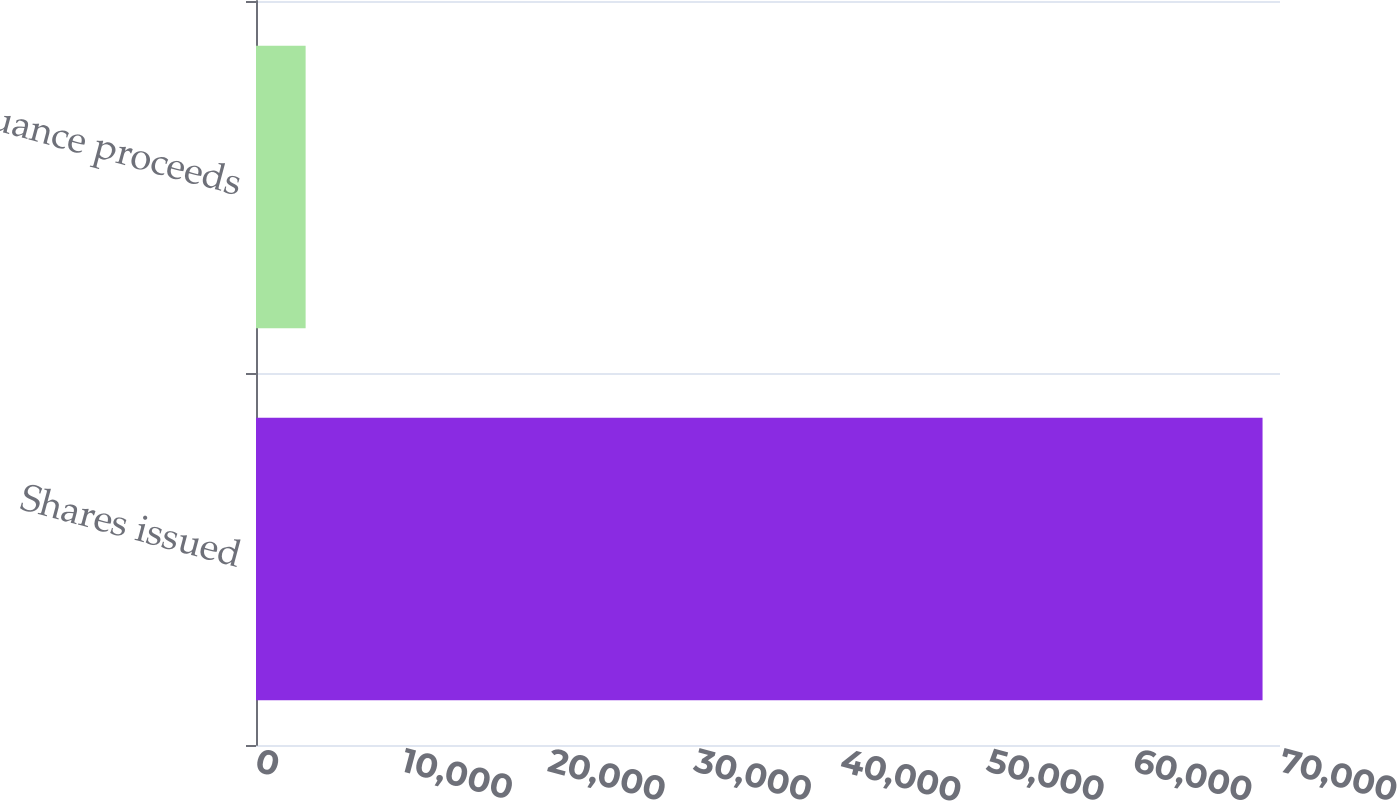Convert chart. <chart><loc_0><loc_0><loc_500><loc_500><bar_chart><fcel>Shares issued<fcel>Issuance proceeds<nl><fcel>68807<fcel>3392<nl></chart> 